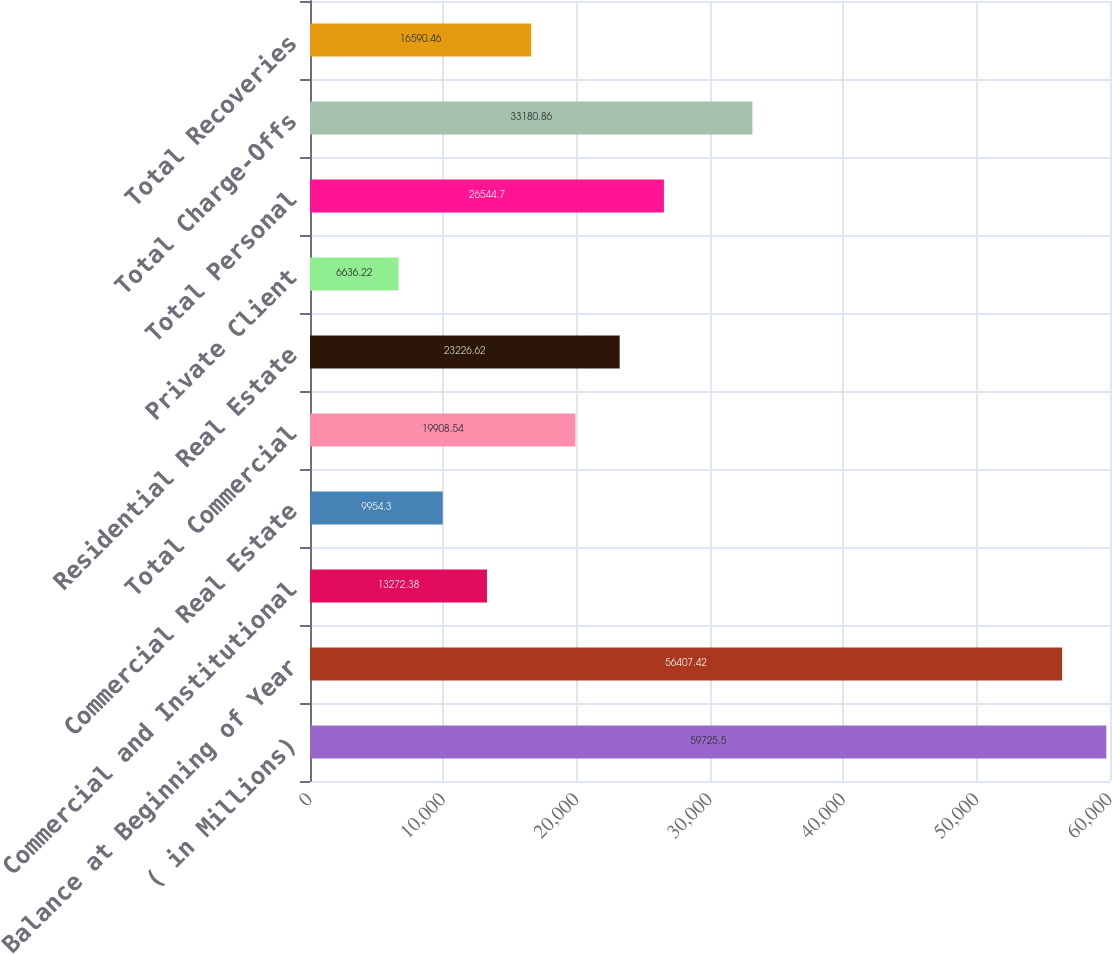Convert chart to OTSL. <chart><loc_0><loc_0><loc_500><loc_500><bar_chart><fcel>( in Millions)<fcel>Balance at Beginning of Year<fcel>Commercial and Institutional<fcel>Commercial Real Estate<fcel>Total Commercial<fcel>Residential Real Estate<fcel>Private Client<fcel>Total Personal<fcel>Total Charge-Offs<fcel>Total Recoveries<nl><fcel>59725.5<fcel>56407.4<fcel>13272.4<fcel>9954.3<fcel>19908.5<fcel>23226.6<fcel>6636.22<fcel>26544.7<fcel>33180.9<fcel>16590.5<nl></chart> 